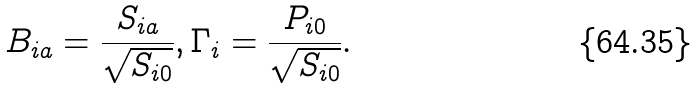<formula> <loc_0><loc_0><loc_500><loc_500>B _ { i a } = \frac { S _ { i a } } { \sqrt { S _ { i 0 } } } , \Gamma _ { i } = \frac { P _ { i 0 } } { \sqrt { S _ { i 0 } } } .</formula> 